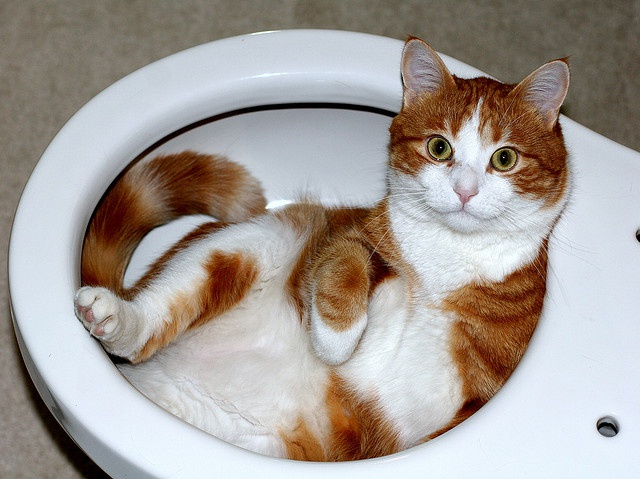Describe the objects in this image and their specific colors. I can see cat in gray, lightgray, maroon, darkgray, and brown tones and toilet in gray, lightgray, and darkgray tones in this image. 